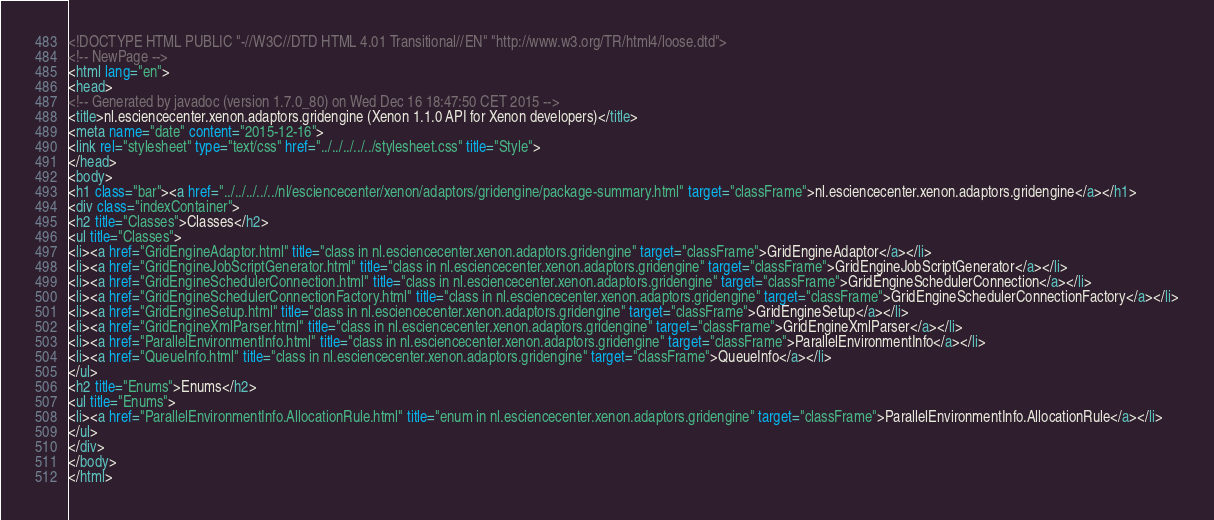<code> <loc_0><loc_0><loc_500><loc_500><_HTML_><!DOCTYPE HTML PUBLIC "-//W3C//DTD HTML 4.01 Transitional//EN" "http://www.w3.org/TR/html4/loose.dtd">
<!-- NewPage -->
<html lang="en">
<head>
<!-- Generated by javadoc (version 1.7.0_80) on Wed Dec 16 18:47:50 CET 2015 -->
<title>nl.esciencecenter.xenon.adaptors.gridengine (Xenon 1.1.0 API for Xenon developers)</title>
<meta name="date" content="2015-12-16">
<link rel="stylesheet" type="text/css" href="../../../../../stylesheet.css" title="Style">
</head>
<body>
<h1 class="bar"><a href="../../../../../nl/esciencecenter/xenon/adaptors/gridengine/package-summary.html" target="classFrame">nl.esciencecenter.xenon.adaptors.gridengine</a></h1>
<div class="indexContainer">
<h2 title="Classes">Classes</h2>
<ul title="Classes">
<li><a href="GridEngineAdaptor.html" title="class in nl.esciencecenter.xenon.adaptors.gridengine" target="classFrame">GridEngineAdaptor</a></li>
<li><a href="GridEngineJobScriptGenerator.html" title="class in nl.esciencecenter.xenon.adaptors.gridengine" target="classFrame">GridEngineJobScriptGenerator</a></li>
<li><a href="GridEngineSchedulerConnection.html" title="class in nl.esciencecenter.xenon.adaptors.gridengine" target="classFrame">GridEngineSchedulerConnection</a></li>
<li><a href="GridEngineSchedulerConnectionFactory.html" title="class in nl.esciencecenter.xenon.adaptors.gridengine" target="classFrame">GridEngineSchedulerConnectionFactory</a></li>
<li><a href="GridEngineSetup.html" title="class in nl.esciencecenter.xenon.adaptors.gridengine" target="classFrame">GridEngineSetup</a></li>
<li><a href="GridEngineXmlParser.html" title="class in nl.esciencecenter.xenon.adaptors.gridengine" target="classFrame">GridEngineXmlParser</a></li>
<li><a href="ParallelEnvironmentInfo.html" title="class in nl.esciencecenter.xenon.adaptors.gridengine" target="classFrame">ParallelEnvironmentInfo</a></li>
<li><a href="QueueInfo.html" title="class in nl.esciencecenter.xenon.adaptors.gridengine" target="classFrame">QueueInfo</a></li>
</ul>
<h2 title="Enums">Enums</h2>
<ul title="Enums">
<li><a href="ParallelEnvironmentInfo.AllocationRule.html" title="enum in nl.esciencecenter.xenon.adaptors.gridengine" target="classFrame">ParallelEnvironmentInfo.AllocationRule</a></li>
</ul>
</div>
</body>
</html>
</code> 